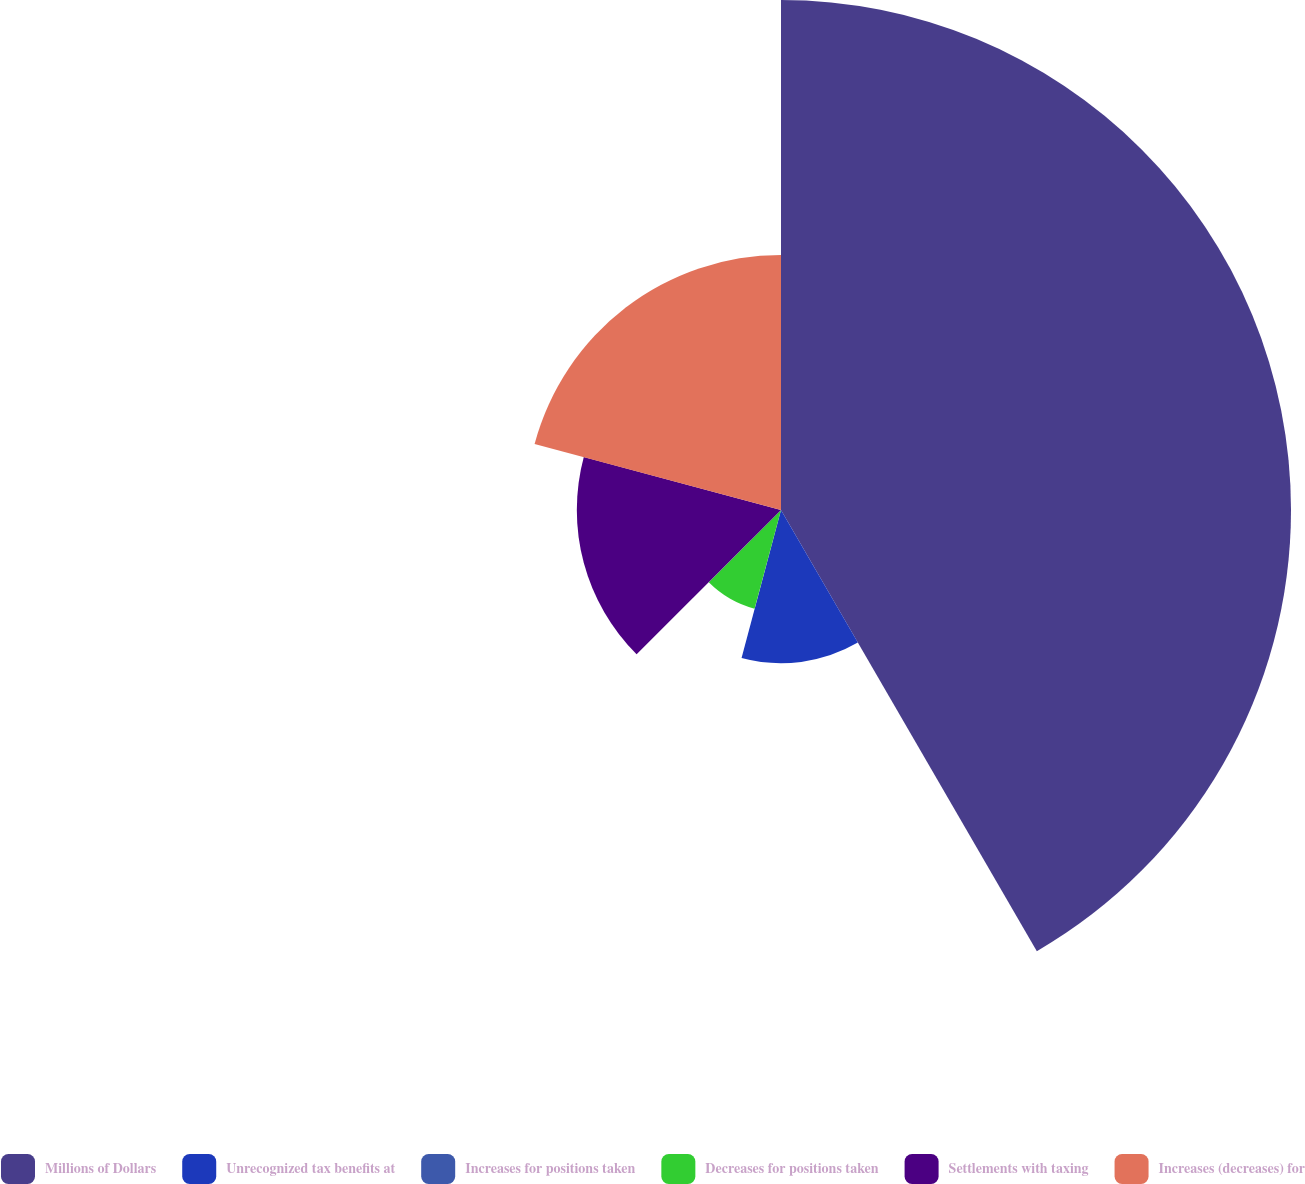Convert chart to OTSL. <chart><loc_0><loc_0><loc_500><loc_500><pie_chart><fcel>Millions of Dollars<fcel>Unrecognized tax benefits at<fcel>Increases for positions taken<fcel>Decreases for positions taken<fcel>Settlements with taxing<fcel>Increases (decreases) for<nl><fcel>41.64%<fcel>12.51%<fcel>0.02%<fcel>8.34%<fcel>16.67%<fcel>20.83%<nl></chart> 